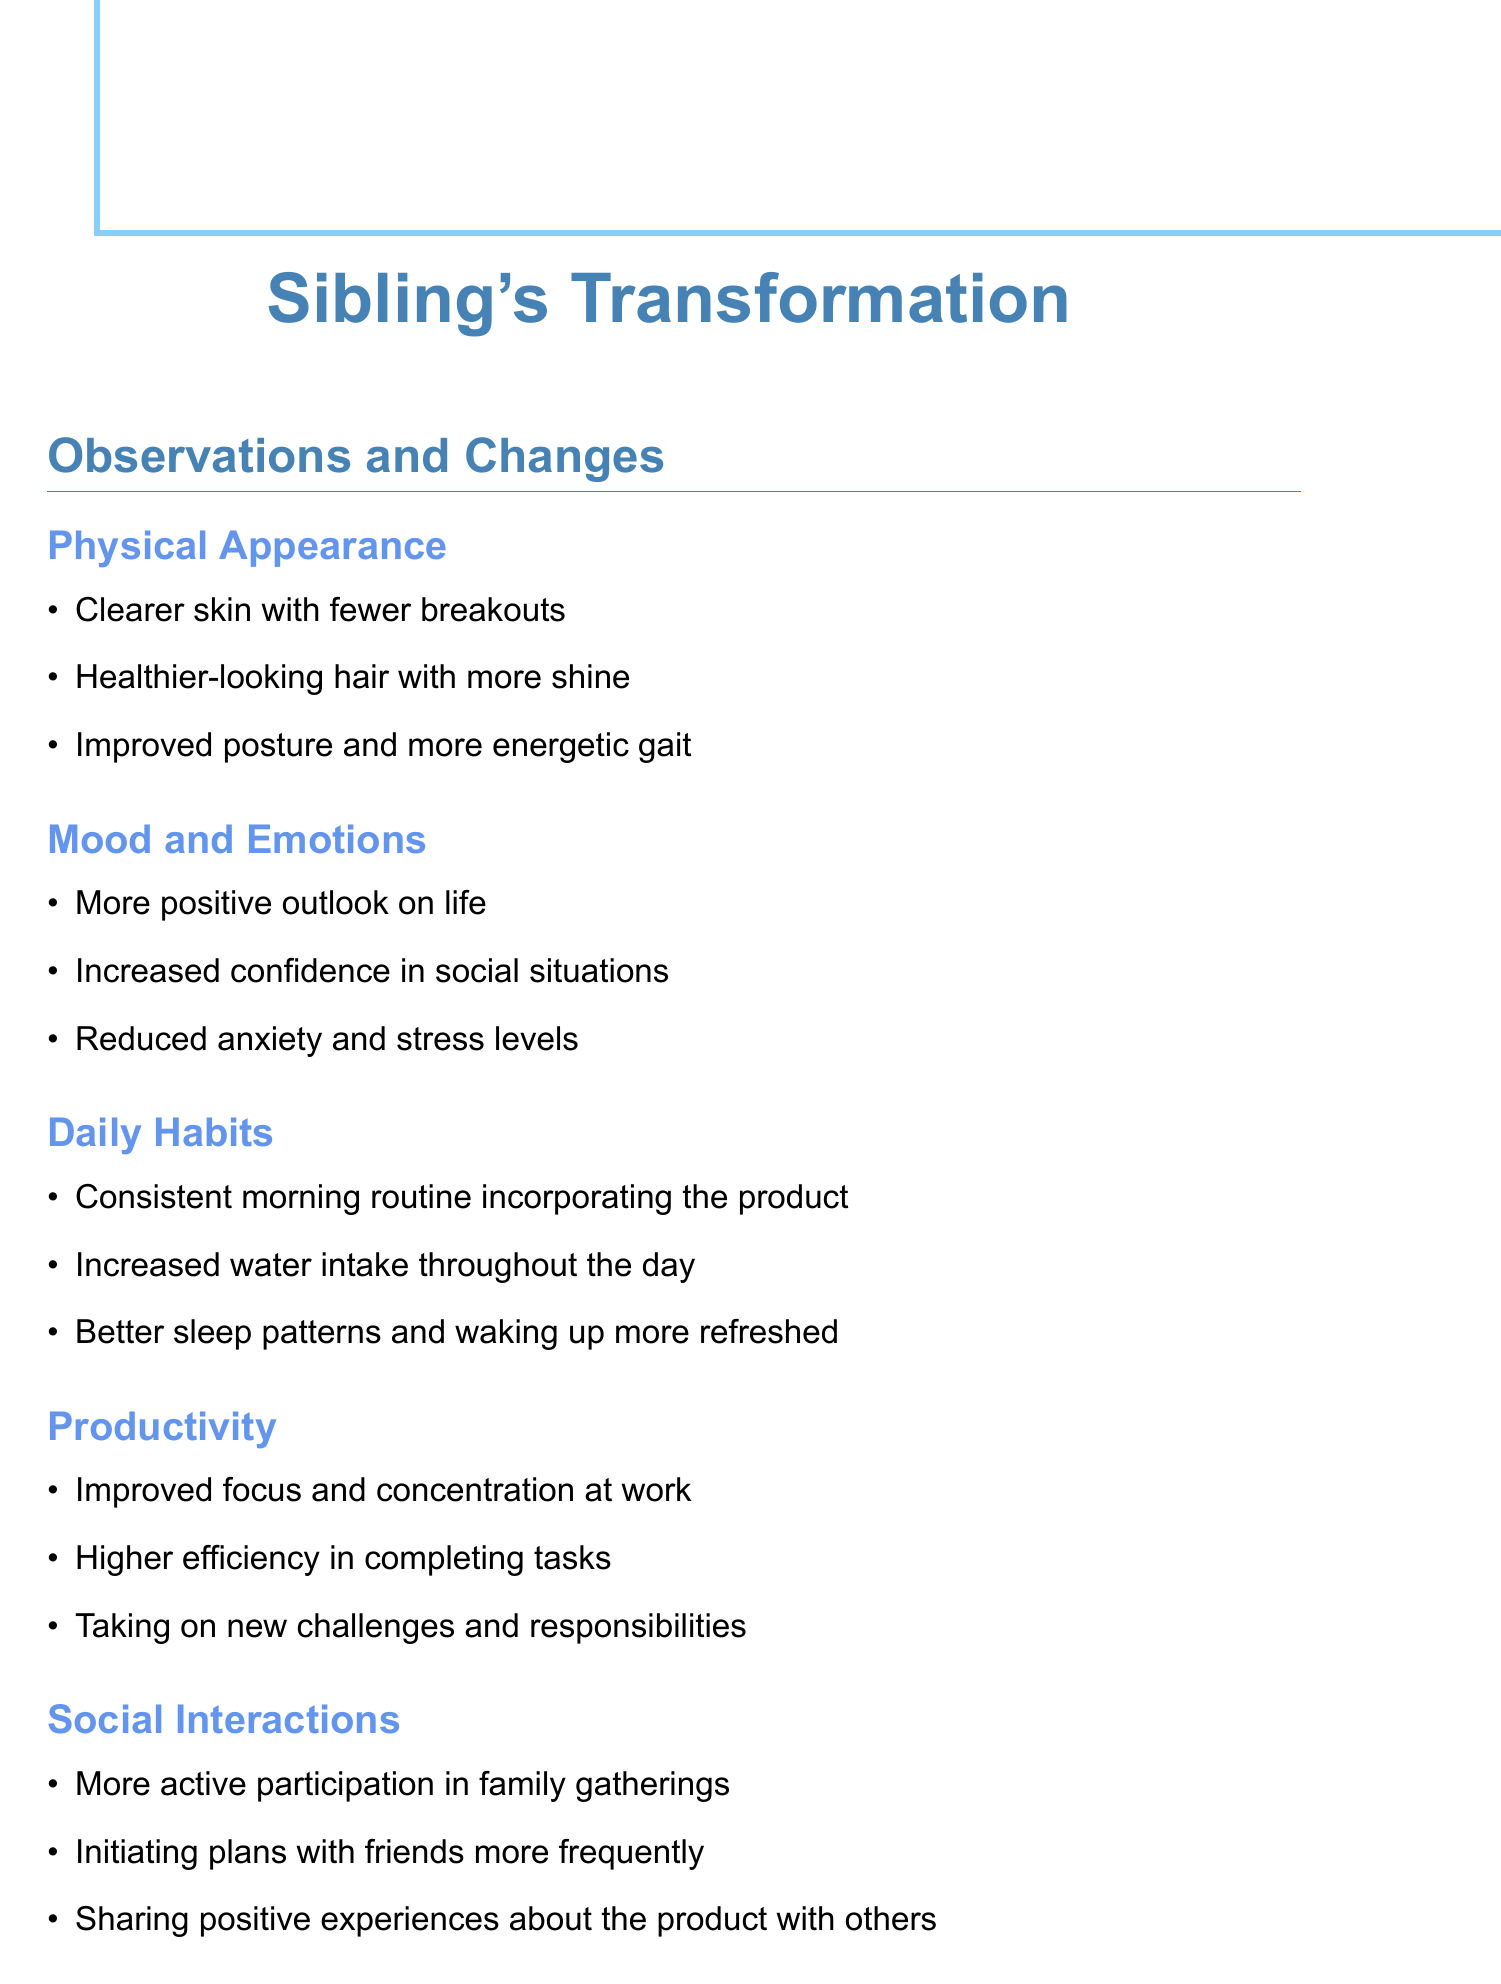What are the changes in physical appearance? The observations list changes in physical appearance such as clearer skin, healthier hair, and improved posture.
Answer: Clearer skin, healthier-looking hair, improved posture How has the mood improved? The document mentions a more positive outlook, increased confidence, and reduced anxiety as improvements in mood.
Answer: More positive outlook, increased confidence, reduced anxiety What daily habit has been established? The notes state a consistent morning routine as a new daily habit since using the product.
Answer: Consistent morning routine What productivity improvement is noted? The document highlights that there is improved focus and concentration at work as a productivity change.
Answer: Improved focus and concentration How has social interaction changed? The observations indicate a more active participation in family gatherings as well as initiating plans with friends.
Answer: More active participation in family gatherings What overall health benefit is mentioned? The document reflects a decrease in complaints about minor ailments as an overall health benefit.
Answer: Fewer complaints about minor ailments What is the sibling's transformation described as? The final note in the document refers to the sibling's transformation from skepticism to belief in the product.
Answer: From a skeptical sibling to a true believer 